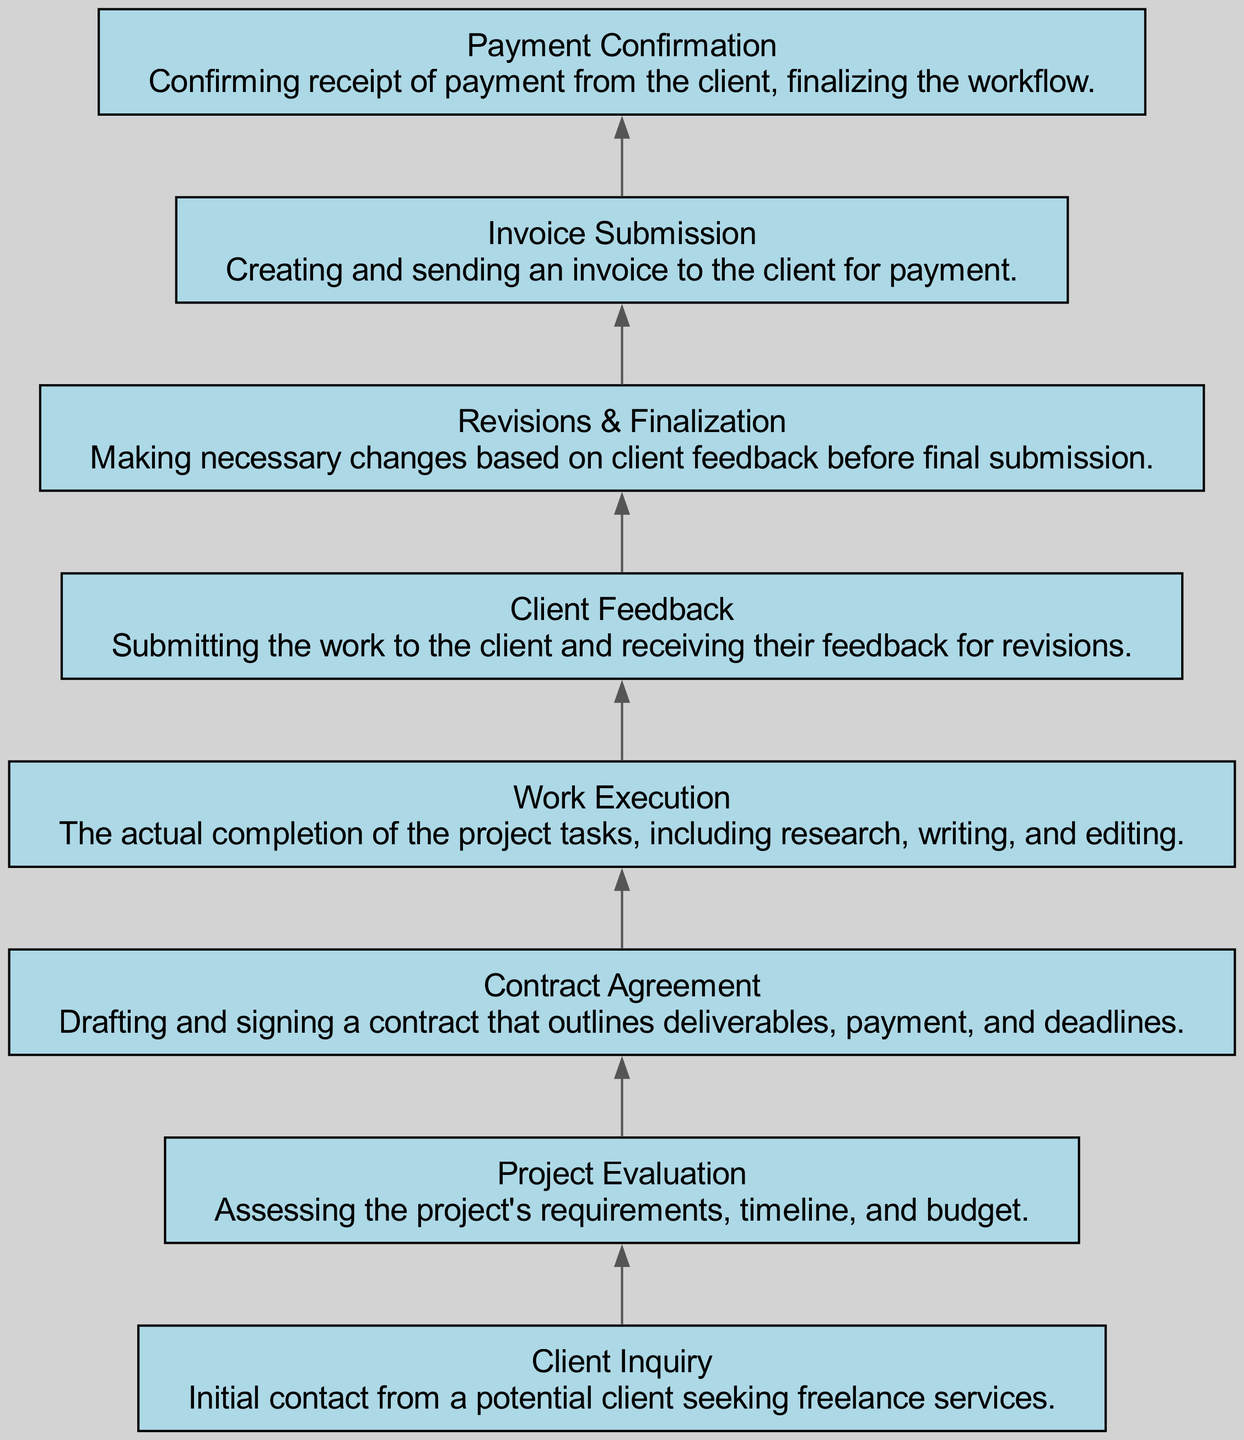What is the first step in the workflow? The first step in the workflow is labeled as "Client Inquiry," which indicates the initial contact from a potential client seeking freelance services.
Answer: Client Inquiry How many total nodes are there in the flow chart? The flow chart contains eight nodes, each representing a different stage in managing freelance workflows.
Answer: Eight What is the last step in the workflow? The last step in the workflow is "Payment Confirmation," which concludes the process after confirming receipt of payment from the client.
Answer: Payment Confirmation What connects "Work Execution" and "Client Feedback"? The node labeled as "Client Feedback" is directly connected to "Work Execution," indicating that after executing work, feedback is sought from the client.
Answer: Client Feedback Which step comes immediately after "Contract Agreement"? The step that comes immediately after "Contract Agreement" in the workflow is "Work Execution," meaning that once a contract is agreed upon, work on the project begins.
Answer: Work Execution What is the relationship between "Client Feedback" and "Revisions & Finalization"? "Client Feedback" leads to "Revisions & Finalization," showing that feedback from the client necessitates revisions before the final work is submitted.
Answer: Revisions & Finalization How many steps are there between "Project Evaluation" and "Invoice Submission"? There are three steps between "Project Evaluation" and "Invoice Submission": "Contract Agreement," "Work Execution," and "Client Feedback."
Answer: Three What is the significance of the direction of the arrows in this flow chart? The arrows, drawn from bottom to top, indicate the sequential flow of actions taken in managing freelance workflows, signifying the order in which tasks are completed.
Answer: Sequential flow What will occur after receiving "Client Feedback"? After receiving "Client Feedback," the next step is to make necessary changes during the "Revisions & Finalization" phase before final submission of the work.
Answer: Revisions & Finalization 